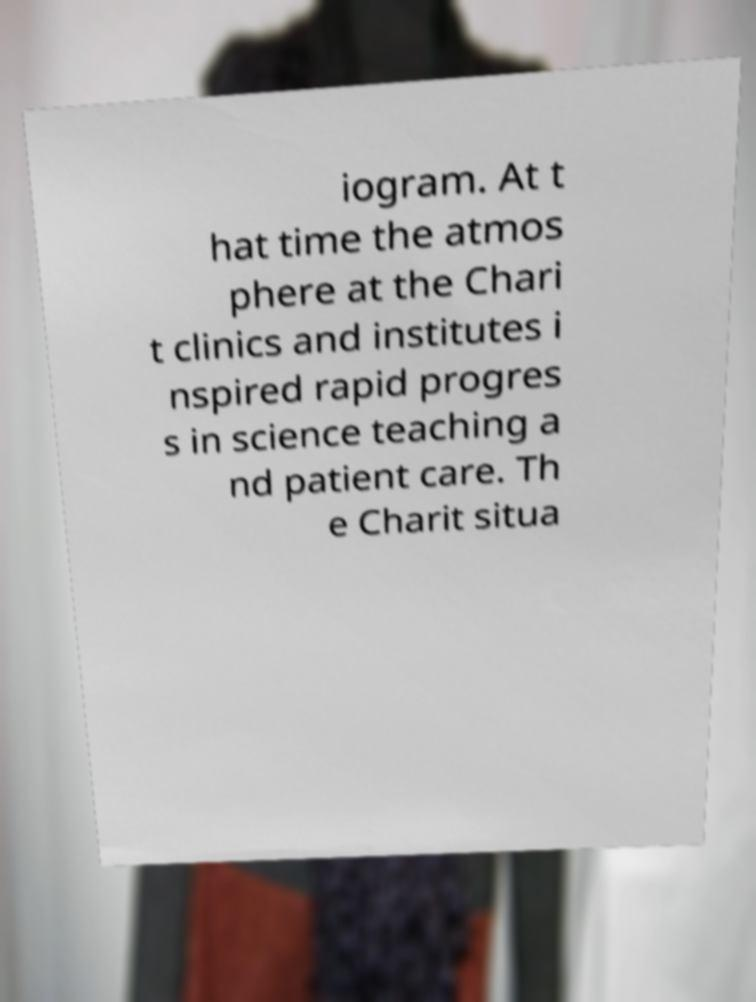For documentation purposes, I need the text within this image transcribed. Could you provide that? iogram. At t hat time the atmos phere at the Chari t clinics and institutes i nspired rapid progres s in science teaching a nd patient care. Th e Charit situa 